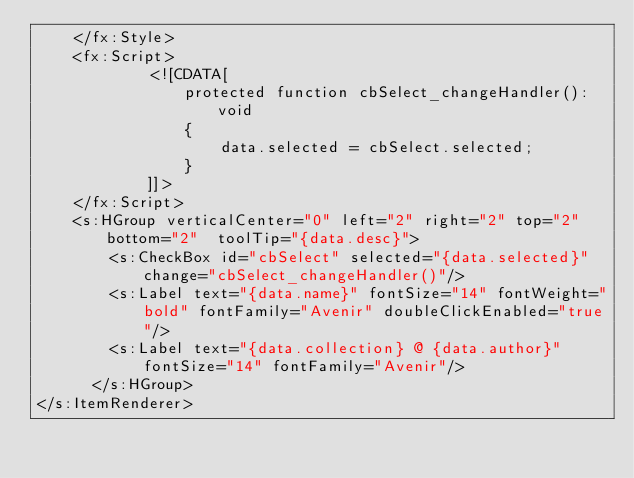<code> <loc_0><loc_0><loc_500><loc_500><_XML_>    </fx:Style>
    <fx:Script>
            <![CDATA[
                protected function cbSelect_changeHandler():void
                {
                    data.selected = cbSelect.selected;
                }
            ]]>
    </fx:Script>
    <s:HGroup verticalCenter="0" left="2" right="2" top="2" bottom="2"  toolTip="{data.desc}">
        <s:CheckBox id="cbSelect" selected="{data.selected}" change="cbSelect_changeHandler()"/>
        <s:Label text="{data.name}" fontSize="14" fontWeight="bold" fontFamily="Avenir" doubleClickEnabled="true"/>
        <s:Label text="{data.collection} @ {data.author}" fontSize="14" fontFamily="Avenir"/>
      </s:HGroup>
</s:ItemRenderer></code> 